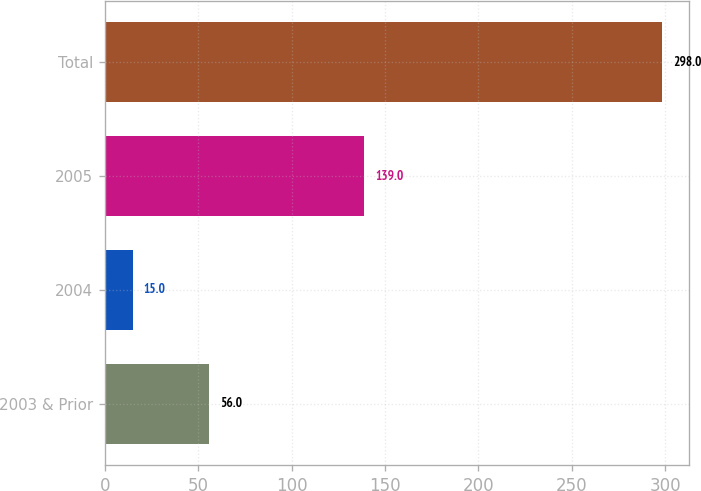Convert chart. <chart><loc_0><loc_0><loc_500><loc_500><bar_chart><fcel>2003 & Prior<fcel>2004<fcel>2005<fcel>Total<nl><fcel>56<fcel>15<fcel>139<fcel>298<nl></chart> 